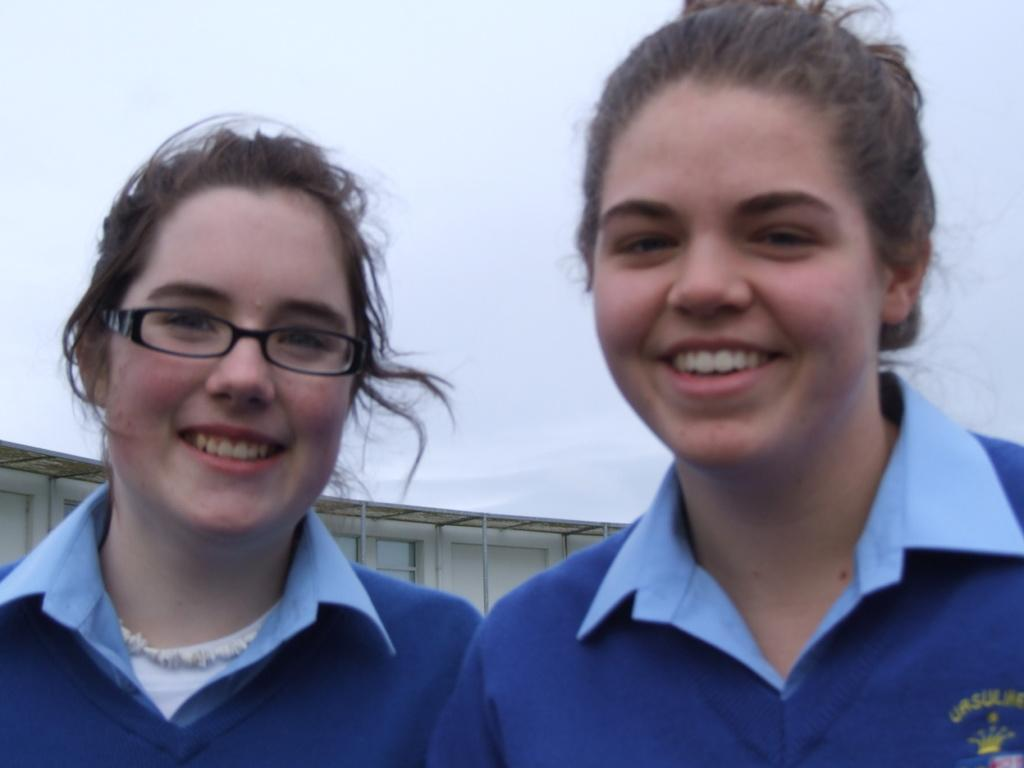How many people are in the image? There are two ladies in the image. What can be seen in the background of the image? There is a white color object and the sky visible in the background of the image. What news is the lady on the left reading from her pocket in the image? There is no news or pocket visible in the image; the ladies are not holding any objects. 